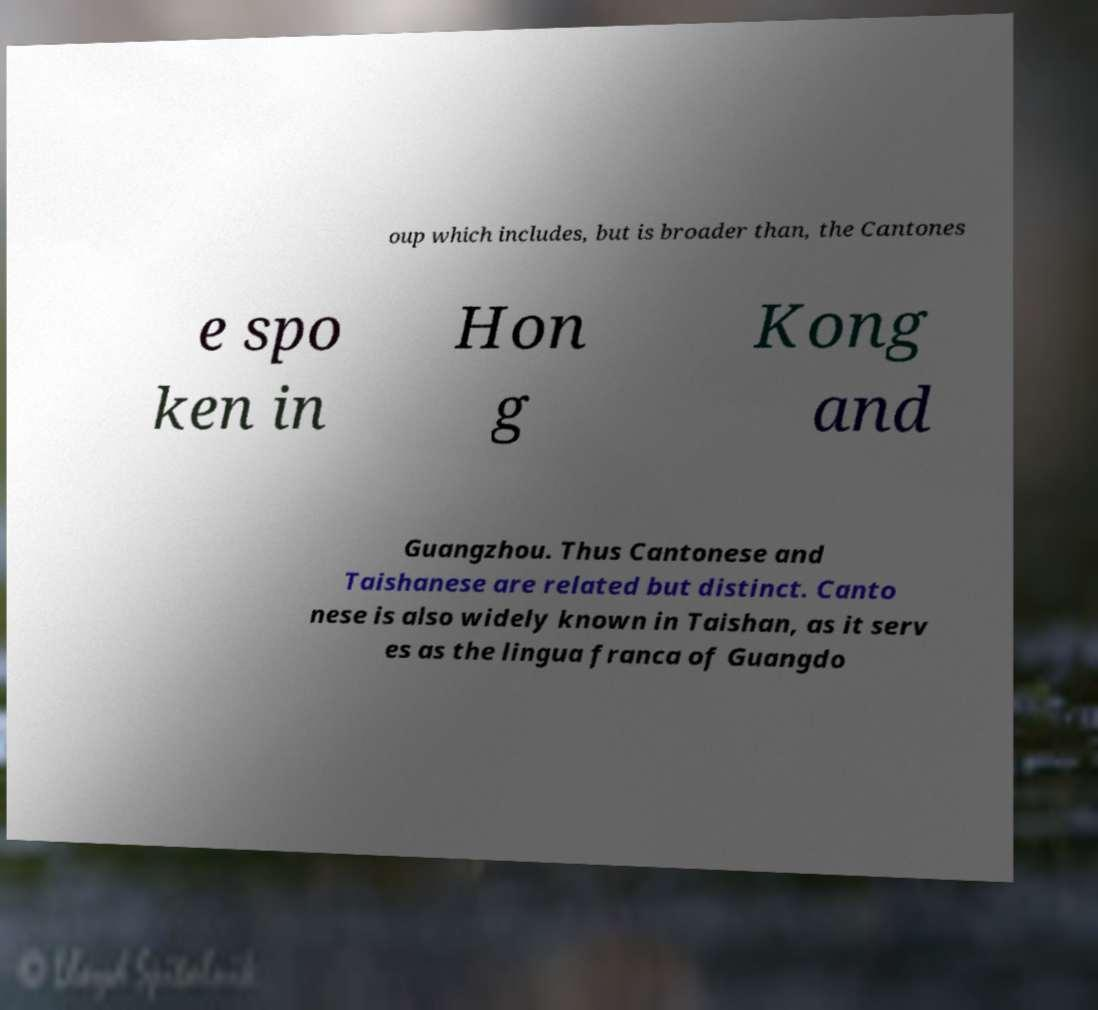There's text embedded in this image that I need extracted. Can you transcribe it verbatim? oup which includes, but is broader than, the Cantones e spo ken in Hon g Kong and Guangzhou. Thus Cantonese and Taishanese are related but distinct. Canto nese is also widely known in Taishan, as it serv es as the lingua franca of Guangdo 